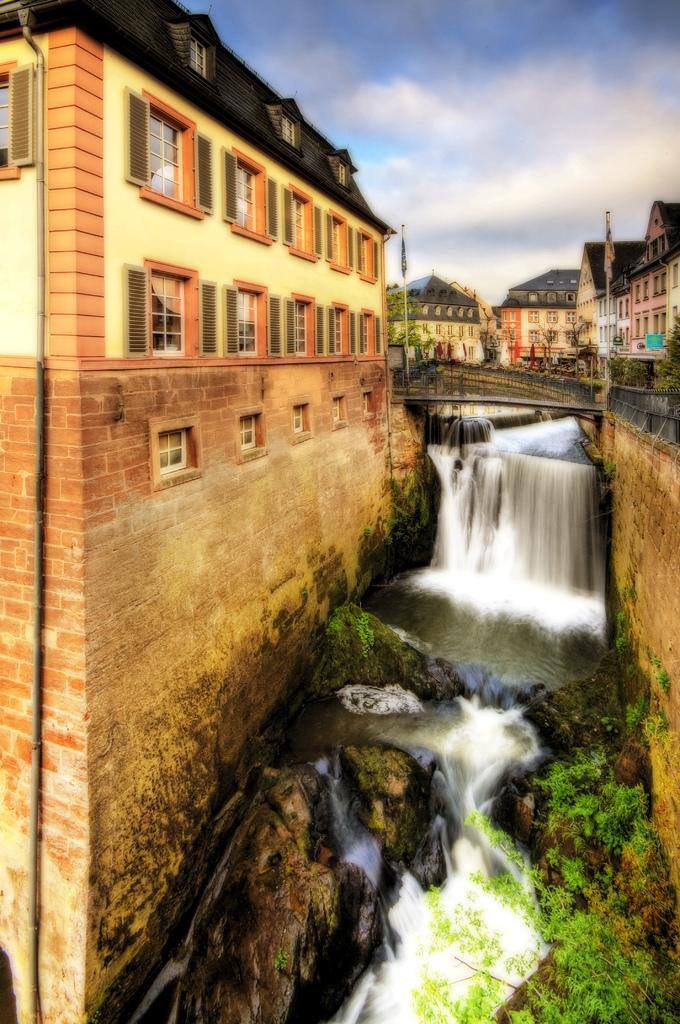What type of structures can be seen in the image? There are buildings in the image. What other objects are present in the image? There are poles, a bridge, and plants visible in the image. What natural feature is at the bottom of the image? There is a waterfall at the bottom of the image. What type of terrain is present in the image? There are rocks in the image. What is visible at the top of the image? The sky is visible at the top of the image. How many mice can be seen running on the bridge in the image? There are no mice present in the image; it features buildings, poles, a bridge, a waterfall, plants, rocks, and a visible sky. Is there a spy observing the waterfall in the image? There is no indication of a spy or any person in the image; it primarily focuses on the natural and man-made structures. 